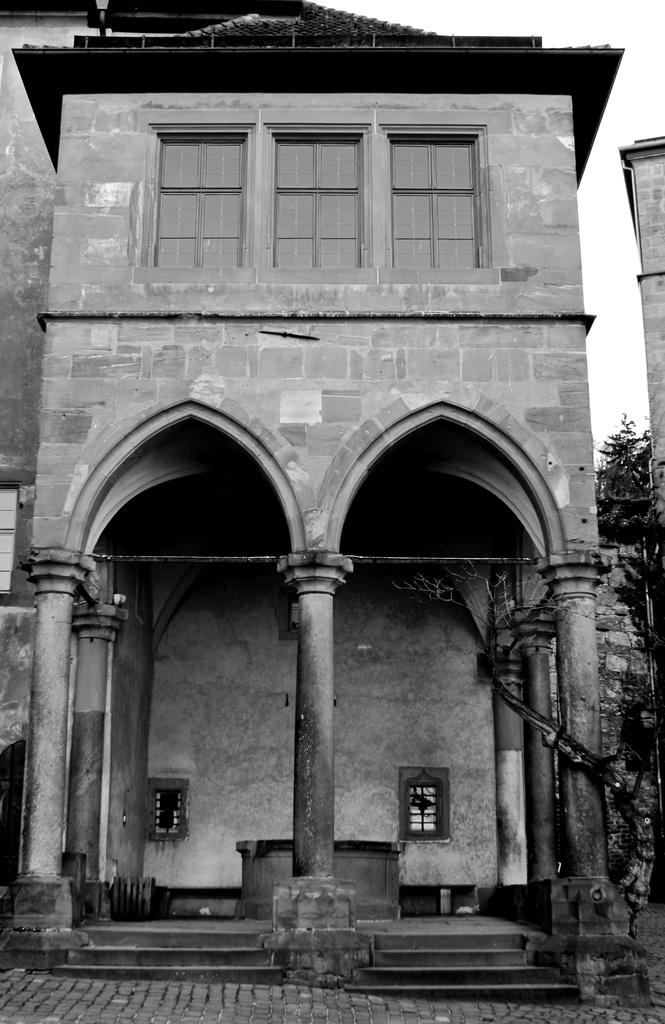What is the color scheme of the image? The image is black and white. What type of structure can be seen in the image? There is a building in the image. What are the tall, thin objects in the image? There are poles in the image. What type of vegetation is present in the image? There are trees in the image. What is visible at the top of the image? The sky is visible in the image. Can you tell me how many kittens are playing with a lead and a twig in the image? There are no kittens, leads, or twigs present in the image. 